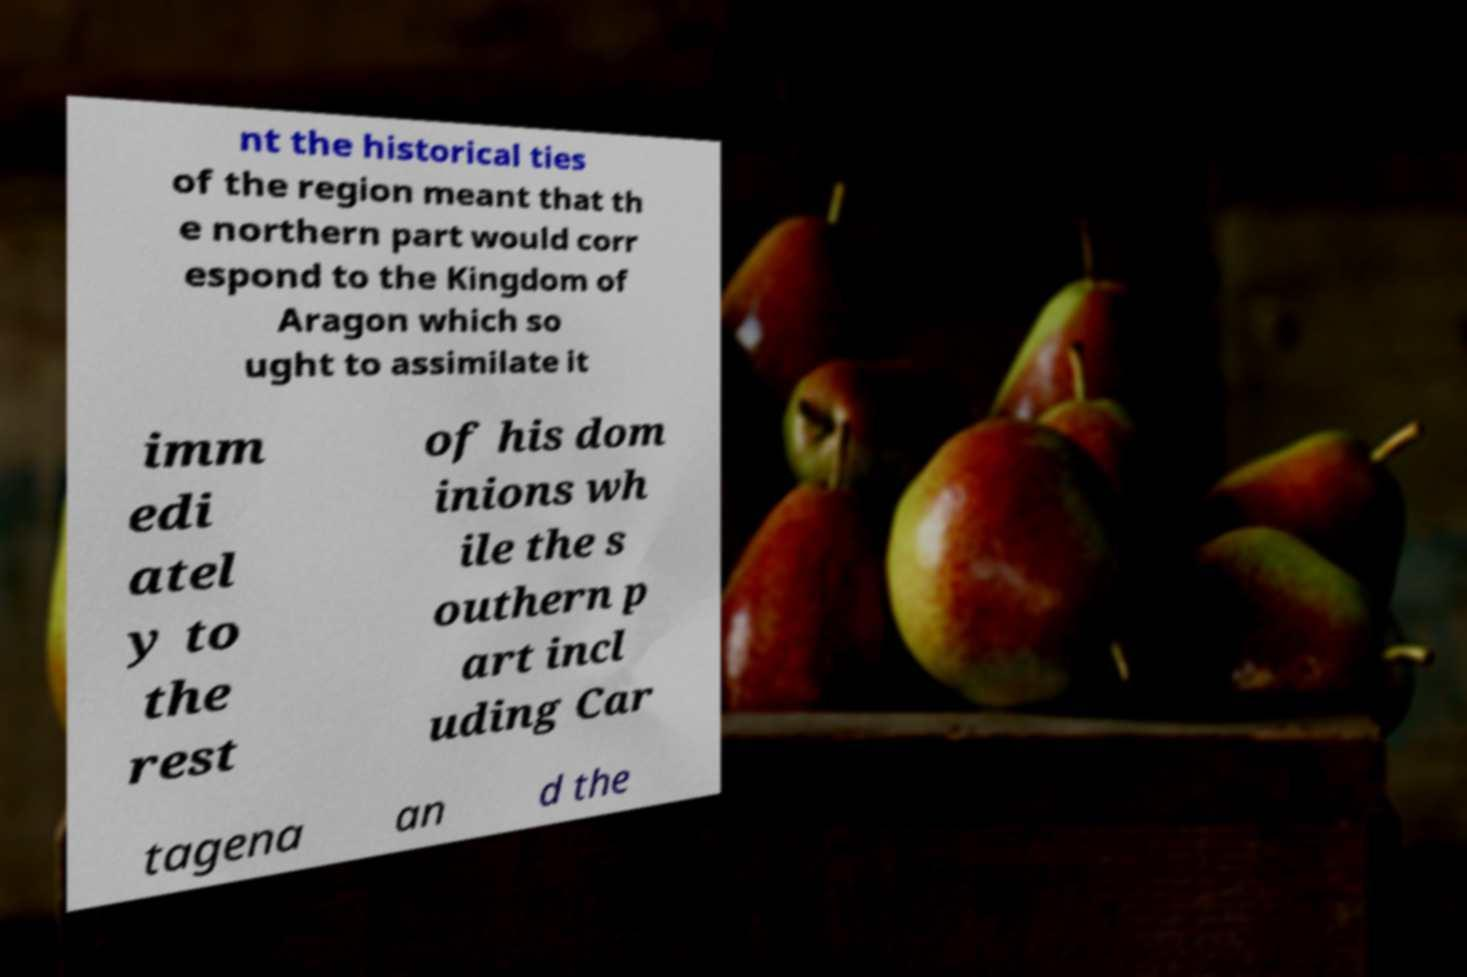Please read and relay the text visible in this image. What does it say? nt the historical ties of the region meant that th e northern part would corr espond to the Kingdom of Aragon which so ught to assimilate it imm edi atel y to the rest of his dom inions wh ile the s outhern p art incl uding Car tagena an d the 